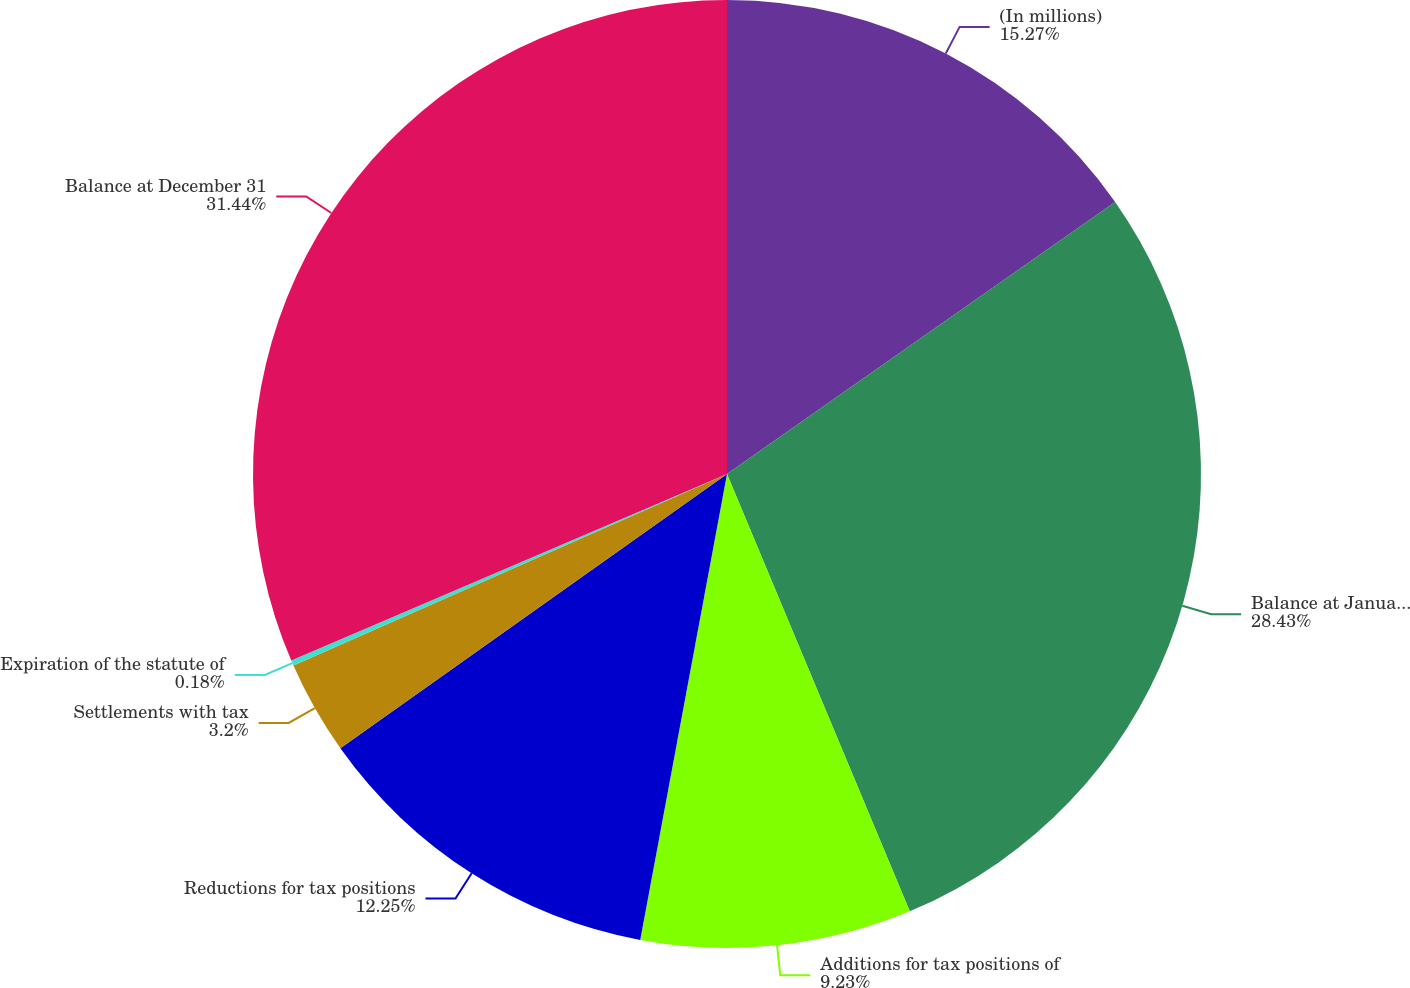Convert chart. <chart><loc_0><loc_0><loc_500><loc_500><pie_chart><fcel>(In millions)<fcel>Balance at January 1<fcel>Additions for tax positions of<fcel>Reductions for tax positions<fcel>Settlements with tax<fcel>Expiration of the statute of<fcel>Balance at December 31<nl><fcel>15.27%<fcel>28.43%<fcel>9.23%<fcel>12.25%<fcel>3.2%<fcel>0.18%<fcel>31.44%<nl></chart> 